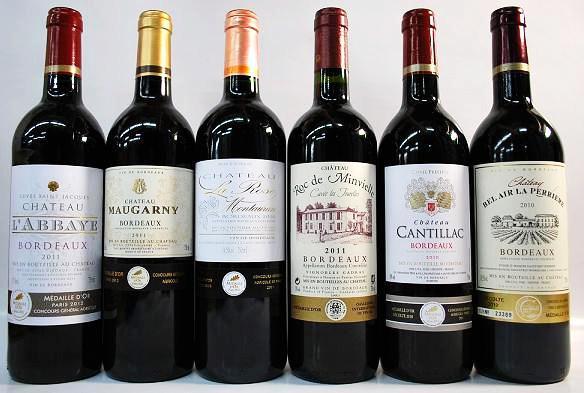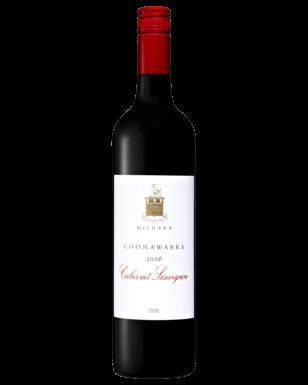The first image is the image on the left, the second image is the image on the right. For the images shown, is this caption "There are no more than three wine bottles in the left image." true? Answer yes or no. No. The first image is the image on the left, the second image is the image on the right. Examine the images to the left and right. Is the description "Exactly six bottles of wine are capped and have labels, and are divided into two groups, at least two bottles in each group." accurate? Answer yes or no. No. 